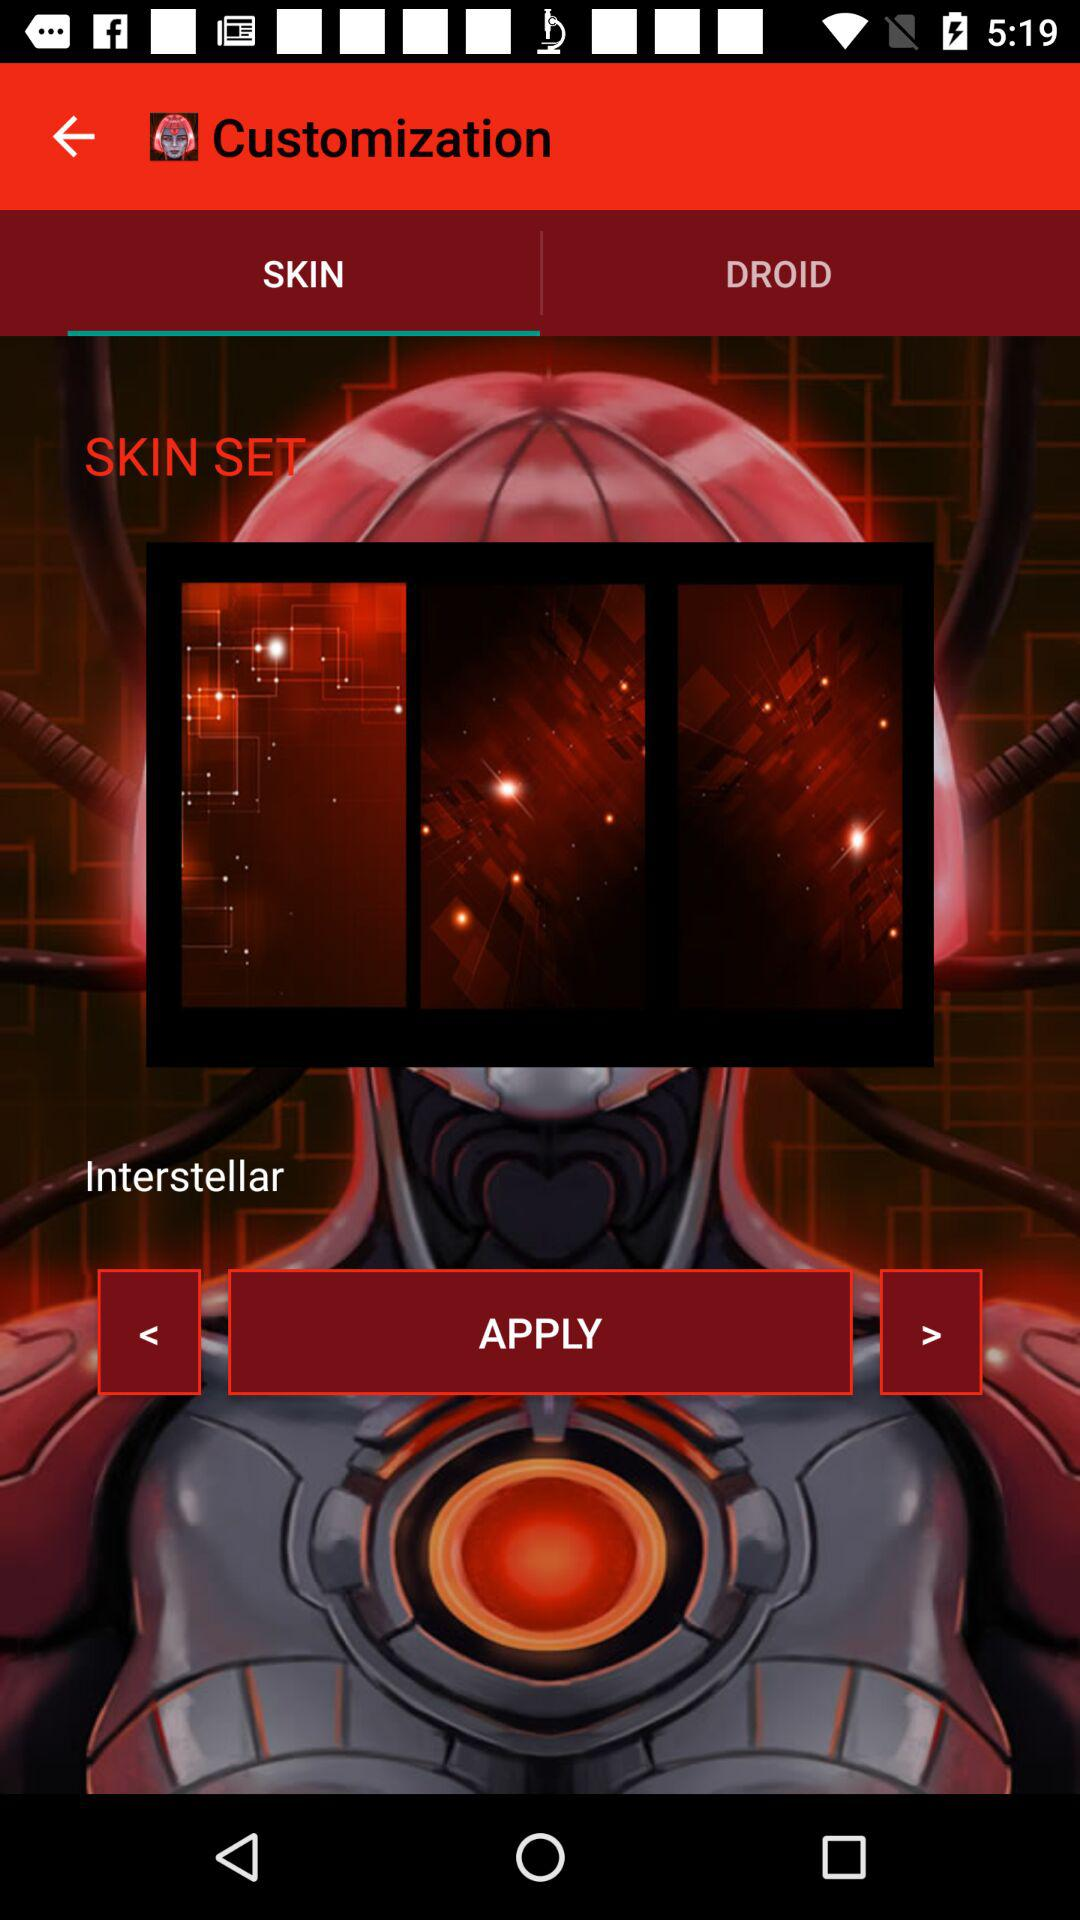Which tab am I using? You are using the "SKIN" tab. 